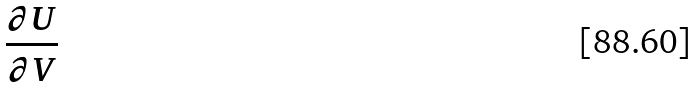Convert formula to latex. <formula><loc_0><loc_0><loc_500><loc_500>\frac { \partial U } { \partial V }</formula> 